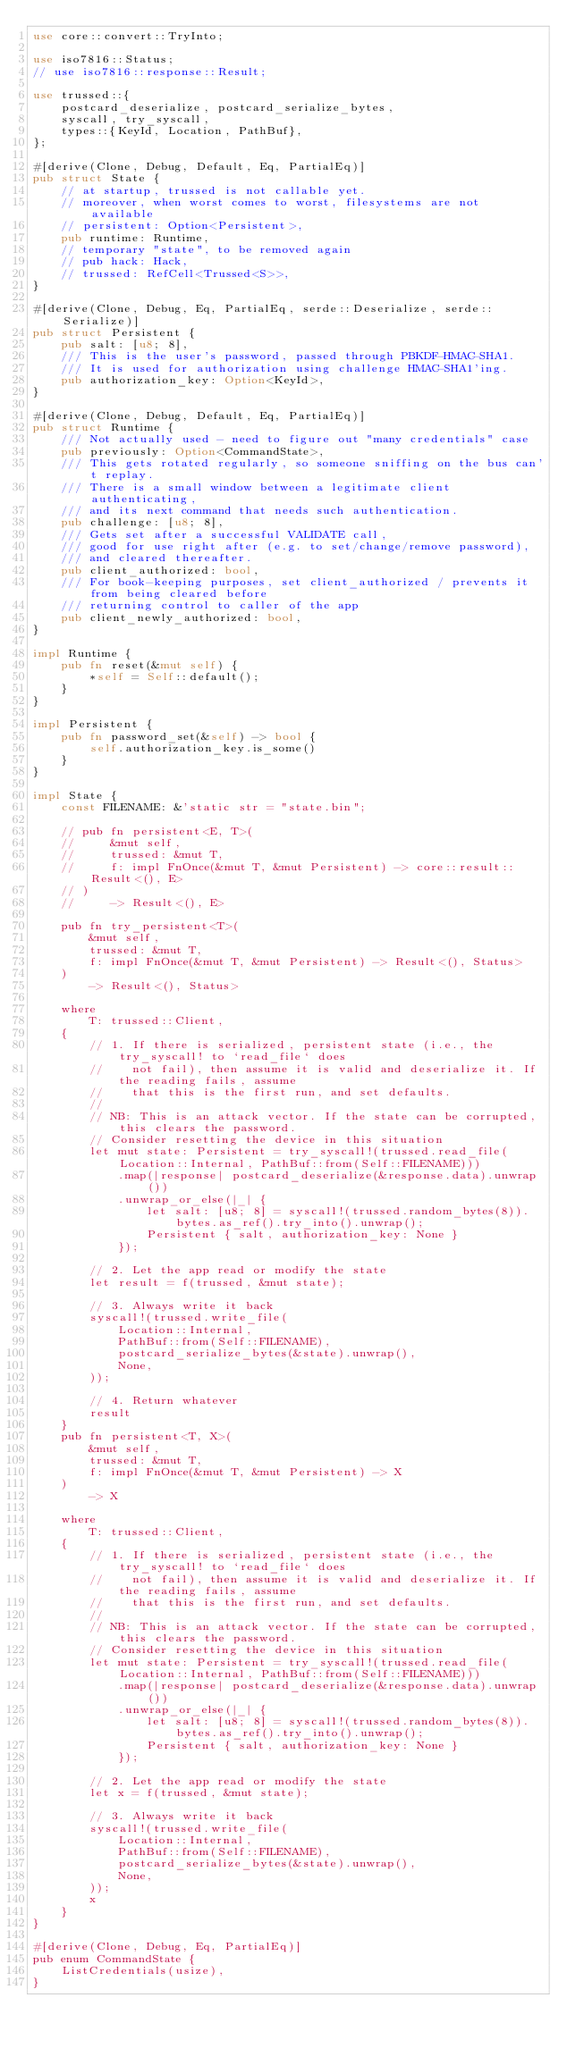Convert code to text. <code><loc_0><loc_0><loc_500><loc_500><_Rust_>use core::convert::TryInto;

use iso7816::Status;
// use iso7816::response::Result;

use trussed::{
    postcard_deserialize, postcard_serialize_bytes,
    syscall, try_syscall,
    types::{KeyId, Location, PathBuf},
};

#[derive(Clone, Debug, Default, Eq, PartialEq)]
pub struct State {
    // at startup, trussed is not callable yet.
    // moreover, when worst comes to worst, filesystems are not available
    // persistent: Option<Persistent>,
    pub runtime: Runtime,
    // temporary "state", to be removed again
    // pub hack: Hack,
    // trussed: RefCell<Trussed<S>>,
}

#[derive(Clone, Debug, Eq, PartialEq, serde::Deserialize, serde::Serialize)]
pub struct Persistent {
    pub salt: [u8; 8],
    /// This is the user's password, passed through PBKDF-HMAC-SHA1.
    /// It is used for authorization using challenge HMAC-SHA1'ing.
    pub authorization_key: Option<KeyId>,
}

#[derive(Clone, Debug, Default, Eq, PartialEq)]
pub struct Runtime {
    /// Not actually used - need to figure out "many credentials" case
    pub previously: Option<CommandState>,
    /// This gets rotated regularly, so someone sniffing on the bus can't replay.
    /// There is a small window between a legitimate client authenticating,
    /// and its next command that needs such authentication.
    pub challenge: [u8; 8],
    /// Gets set after a successful VALIDATE call,
    /// good for use right after (e.g. to set/change/remove password),
    /// and cleared thereafter.
    pub client_authorized: bool,
    /// For book-keeping purposes, set client_authorized / prevents it from being cleared before
    /// returning control to caller of the app
    pub client_newly_authorized: bool,
}

impl Runtime {
    pub fn reset(&mut self) {
        *self = Self::default();
    }
}

impl Persistent {
    pub fn password_set(&self) -> bool {
        self.authorization_key.is_some()
    }
}

impl State {
    const FILENAME: &'static str = "state.bin";

    // pub fn persistent<E, T>(
    //     &mut self,
    //     trussed: &mut T,
    //     f: impl FnOnce(&mut T, &mut Persistent) -> core::result::Result<(), E>
    // )
    //     -> Result<(), E>

    pub fn try_persistent<T>(
        &mut self,
        trussed: &mut T,
        f: impl FnOnce(&mut T, &mut Persistent) -> Result<(), Status>
    )
        -> Result<(), Status>

    where
        T: trussed::Client,
    {
        // 1. If there is serialized, persistent state (i.e., the try_syscall! to `read_file` does
        //    not fail), then assume it is valid and deserialize it. If the reading fails, assume
        //    that this is the first run, and set defaults.
        //
        // NB: This is an attack vector. If the state can be corrupted, this clears the password.
        // Consider resetting the device in this situation
        let mut state: Persistent = try_syscall!(trussed.read_file(Location::Internal, PathBuf::from(Self::FILENAME)))
            .map(|response| postcard_deserialize(&response.data).unwrap())
            .unwrap_or_else(|_| {
                let salt: [u8; 8] = syscall!(trussed.random_bytes(8)).bytes.as_ref().try_into().unwrap();
                Persistent { salt, authorization_key: None }
            });

        // 2. Let the app read or modify the state
        let result = f(trussed, &mut state);

        // 3. Always write it back
        syscall!(trussed.write_file(
            Location::Internal,
            PathBuf::from(Self::FILENAME),
            postcard_serialize_bytes(&state).unwrap(),
            None,
        ));

        // 4. Return whatever
        result
    }
    pub fn persistent<T, X>(
        &mut self,
        trussed: &mut T,
        f: impl FnOnce(&mut T, &mut Persistent) -> X
    )
        -> X

    where
        T: trussed::Client,
    {
        // 1. If there is serialized, persistent state (i.e., the try_syscall! to `read_file` does
        //    not fail), then assume it is valid and deserialize it. If the reading fails, assume
        //    that this is the first run, and set defaults.
        //
        // NB: This is an attack vector. If the state can be corrupted, this clears the password.
        // Consider resetting the device in this situation
        let mut state: Persistent = try_syscall!(trussed.read_file(Location::Internal, PathBuf::from(Self::FILENAME)))
            .map(|response| postcard_deserialize(&response.data).unwrap())
            .unwrap_or_else(|_| {
                let salt: [u8; 8] = syscall!(trussed.random_bytes(8)).bytes.as_ref().try_into().unwrap();
                Persistent { salt, authorization_key: None }
            });

        // 2. Let the app read or modify the state
        let x = f(trussed, &mut state);

        // 3. Always write it back
        syscall!(trussed.write_file(
            Location::Internal,
            PathBuf::from(Self::FILENAME),
            postcard_serialize_bytes(&state).unwrap(),
            None,
        ));
        x
    }
}

#[derive(Clone, Debug, Eq, PartialEq)]
pub enum CommandState {
    ListCredentials(usize),
}

</code> 